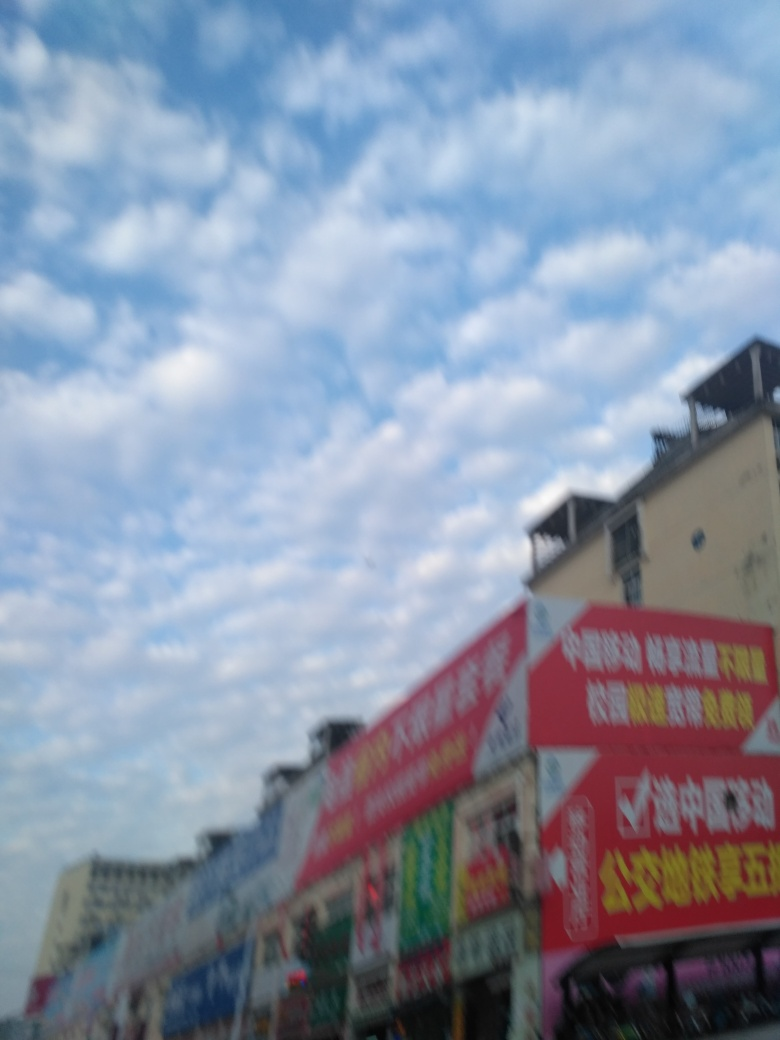What is the weather like in this image? The sky has a decent amount of cloud cover, suggesting an overcast but potentially bright day. There are no visible signs of rain or inclement weather in the provided view. 